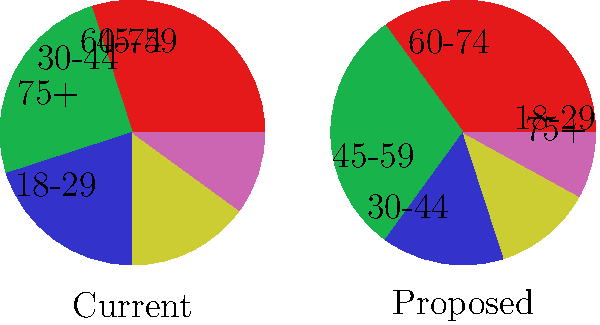As a campaign manager, you've been presented with two pie charts showing the current and proposed allocation of campaign funds across different age demographics. The proposed allocation increases funding for younger voters while reducing it for older groups. How would you justify this reallocation strategy to maximize voter turnout and campaign effectiveness? To justify the reallocation strategy, we need to consider several factors:

1. Voter engagement: Younger voters (18-29 and 30-44) typically have lower turnout rates. Increasing funding for these groups could potentially boost their participation.

2. Population distribution: The proposed allocation might better reflect the current population distribution, ensuring more equitable representation.

3. Return on investment: Younger voters may be more responsive to campaign efforts, potentially offering a higher ROI for campaign spending.

4. Long-term strategy: Engaging younger voters now could build party loyalty for future elections.

5. Digital outreach: Younger demographics are generally more active on social media and digital platforms, which are often more cost-effective for campaigning.

6. Balancing act: While increasing focus on younger voters, the strategy still maintains significant funding for older age groups, acknowledging their traditionally higher turnout rates.

7. Adaptability: This approach shows willingness to adapt to changing demographics and voting patterns, which is crucial for long-term political success.

8. Data-driven decision: The reallocation appears to be based on demographic data, suggesting a pragmatic, evidence-based approach to campaign management.
Answer: Increased younger voter engagement for long-term party growth and cost-effective digital outreach, while maintaining balanced representation across age groups. 